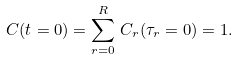<formula> <loc_0><loc_0><loc_500><loc_500>C ( t = 0 ) = \sum _ { r = 0 } ^ { R } \, C _ { r } ( \tau _ { r } = 0 ) = 1 .</formula> 